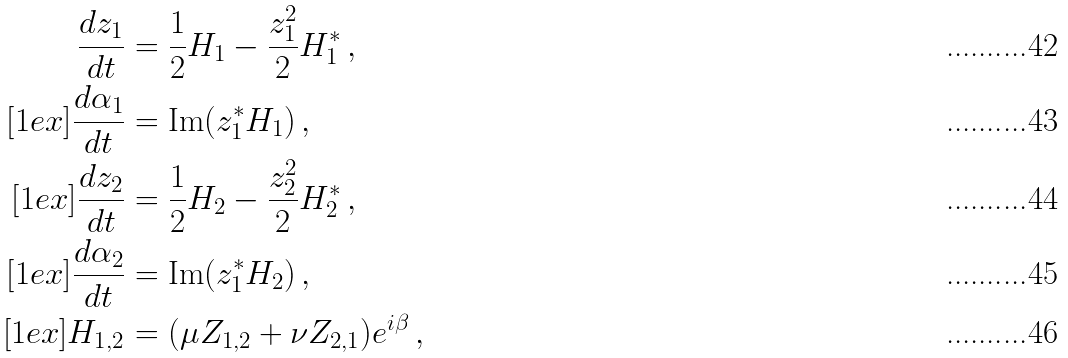<formula> <loc_0><loc_0><loc_500><loc_500>\frac { d z _ { 1 } } { d t } & = \frac { 1 } { 2 } H _ { 1 } - \frac { z _ { 1 } ^ { 2 } } { 2 } H _ { 1 } ^ { * } \, , \\ [ 1 e x ] \frac { d \alpha _ { 1 } } { d t } & = \text {Im} ( z _ { 1 } ^ { * } H _ { 1 } ) \, , \\ [ 1 e x ] \frac { d z _ { 2 } } { d t } & = \frac { 1 } { 2 } H _ { 2 } - \frac { z _ { 2 } ^ { 2 } } { 2 } H _ { 2 } ^ { * } \, , \\ [ 1 e x ] \frac { d \alpha _ { 2 } } { d t } & = \text {Im} ( z _ { 1 } ^ { * } H _ { 2 } ) \, , \\ [ 1 e x ] H _ { 1 , 2 } & = ( \mu Z _ { 1 , 2 } + \nu Z _ { 2 , 1 } ) e ^ { i \beta } \, ,</formula> 